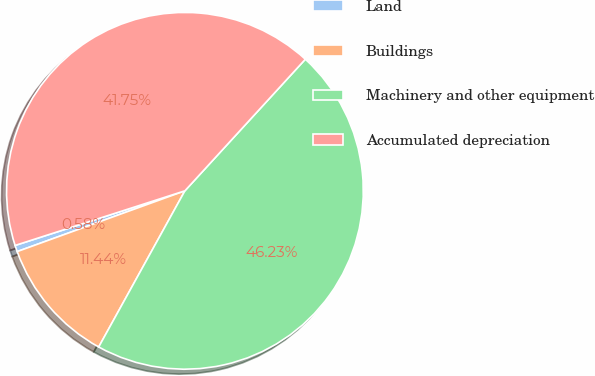<chart> <loc_0><loc_0><loc_500><loc_500><pie_chart><fcel>Land<fcel>Buildings<fcel>Machinery and other equipment<fcel>Accumulated depreciation<nl><fcel>0.58%<fcel>11.44%<fcel>46.23%<fcel>41.75%<nl></chart> 